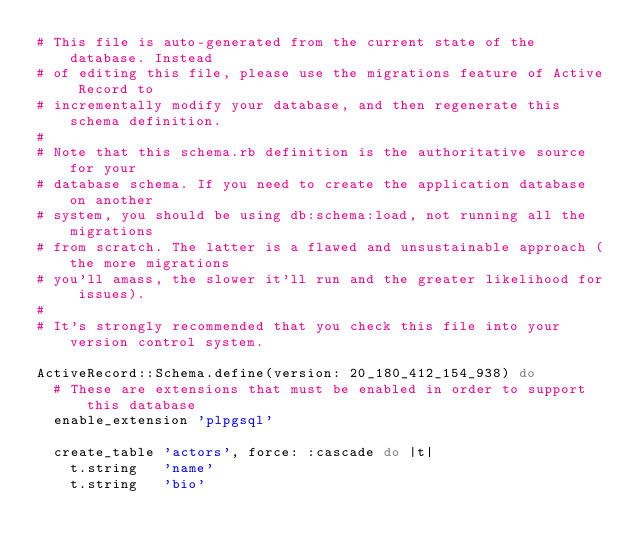<code> <loc_0><loc_0><loc_500><loc_500><_Ruby_># This file is auto-generated from the current state of the database. Instead
# of editing this file, please use the migrations feature of Active Record to
# incrementally modify your database, and then regenerate this schema definition.
#
# Note that this schema.rb definition is the authoritative source for your
# database schema. If you need to create the application database on another
# system, you should be using db:schema:load, not running all the migrations
# from scratch. The latter is a flawed and unsustainable approach (the more migrations
# you'll amass, the slower it'll run and the greater likelihood for issues).
#
# It's strongly recommended that you check this file into your version control system.

ActiveRecord::Schema.define(version: 20_180_412_154_938) do
  # These are extensions that must be enabled in order to support this database
  enable_extension 'plpgsql'

  create_table 'actors', force: :cascade do |t|
    t.string   'name'
    t.string   'bio'</code> 